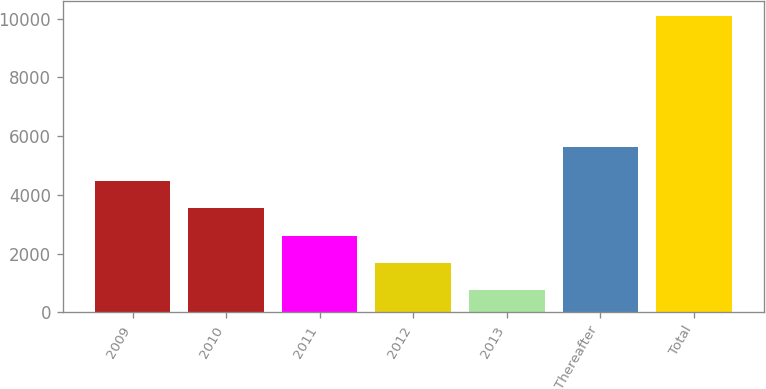Convert chart. <chart><loc_0><loc_0><loc_500><loc_500><bar_chart><fcel>2009<fcel>2010<fcel>2011<fcel>2012<fcel>2013<fcel>Thereafter<fcel>Total<nl><fcel>4478.8<fcel>3545.6<fcel>2612.4<fcel>1679.2<fcel>746<fcel>5614<fcel>10078<nl></chart> 